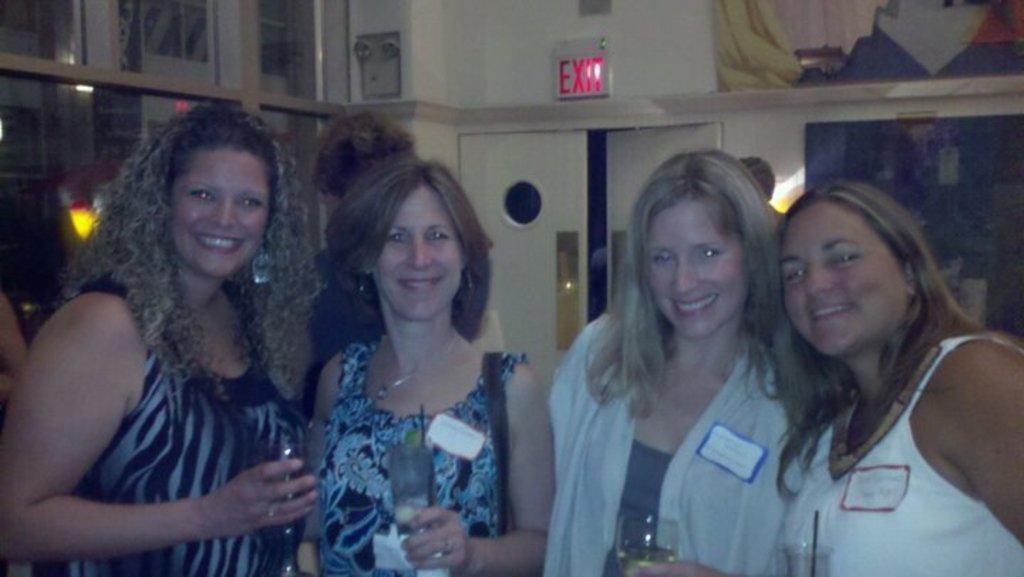Please provide a concise description of this image. In this image I can see few people smiling and holding glasses. Back I can see few objects,wall,lights and the door. 